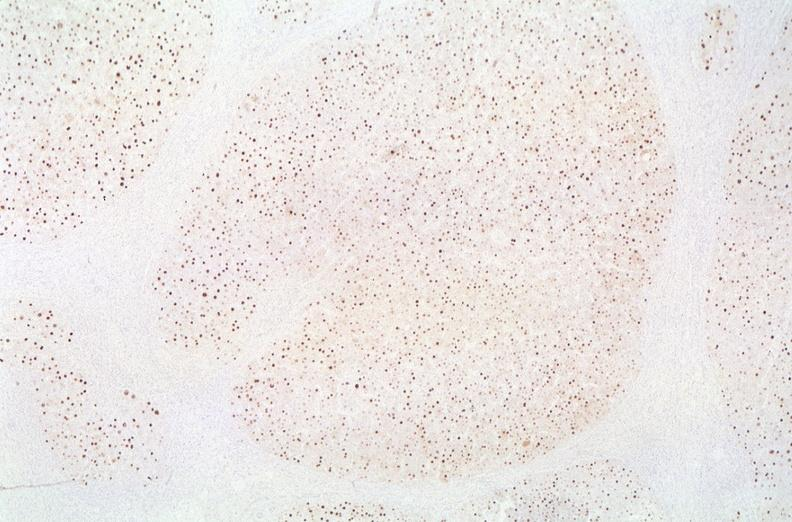what is present?
Answer the question using a single word or phrase. Hepatobiliary 